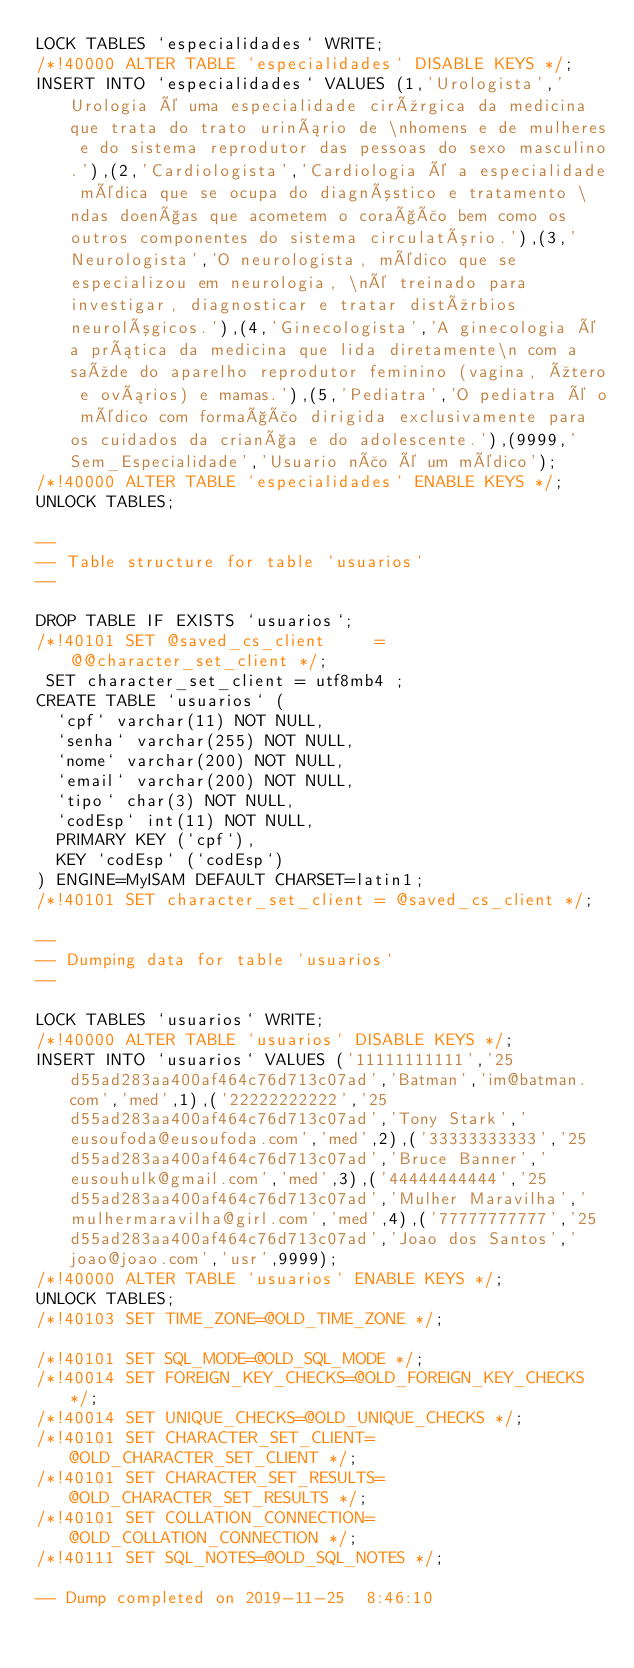Convert code to text. <code><loc_0><loc_0><loc_500><loc_500><_SQL_>LOCK TABLES `especialidades` WRITE;
/*!40000 ALTER TABLE `especialidades` DISABLE KEYS */;
INSERT INTO `especialidades` VALUES (1,'Urologista','Urologia é uma especialidade cirúrgica da medicina que trata do trato urinário de \nhomens e de mulheres e do sistema reprodutor das pessoas do sexo masculino.'),(2,'Cardiologista','Cardiologia é a especialidade médica que se ocupa do diagnóstico e tratamento \ndas doenças que acometem o coração bem como os outros componentes do sistema circulatório.'),(3,'Neurologista','O neurologista, médico que se especializou em neurologia, \né treinado para investigar, diagnosticar e tratar distúrbios neurológicos.'),(4,'Ginecologista','A ginecologia é a prática da medicina que lida diretamente\n com a saúde do aparelho reprodutor feminino (vagina, útero e ovários) e mamas.'),(5,'Pediatra','O pediatra é o médico com formação dirigida exclusivamente para os cuidados da criança e do adolescente.'),(9999,'Sem_Especialidade','Usuario não é um médico');
/*!40000 ALTER TABLE `especialidades` ENABLE KEYS */;
UNLOCK TABLES;

--
-- Table structure for table `usuarios`
--

DROP TABLE IF EXISTS `usuarios`;
/*!40101 SET @saved_cs_client     = @@character_set_client */;
 SET character_set_client = utf8mb4 ;
CREATE TABLE `usuarios` (
  `cpf` varchar(11) NOT NULL,
  `senha` varchar(255) NOT NULL,
  `nome` varchar(200) NOT NULL,
  `email` varchar(200) NOT NULL,
  `tipo` char(3) NOT NULL,
  `codEsp` int(11) NOT NULL,
  PRIMARY KEY (`cpf`),
  KEY `codEsp` (`codEsp`)
) ENGINE=MyISAM DEFAULT CHARSET=latin1;
/*!40101 SET character_set_client = @saved_cs_client */;

--
-- Dumping data for table `usuarios`
--

LOCK TABLES `usuarios` WRITE;
/*!40000 ALTER TABLE `usuarios` DISABLE KEYS */;
INSERT INTO `usuarios` VALUES ('11111111111','25d55ad283aa400af464c76d713c07ad','Batman','im@batman.com','med',1),('22222222222','25d55ad283aa400af464c76d713c07ad','Tony Stark','eusoufoda@eusoufoda.com','med',2),('33333333333','25d55ad283aa400af464c76d713c07ad','Bruce Banner','eusouhulk@gmail.com','med',3),('44444444444','25d55ad283aa400af464c76d713c07ad','Mulher Maravilha','mulhermaravilha@girl.com','med',4),('77777777777','25d55ad283aa400af464c76d713c07ad','Joao dos Santos','joao@joao.com','usr',9999);
/*!40000 ALTER TABLE `usuarios` ENABLE KEYS */;
UNLOCK TABLES;
/*!40103 SET TIME_ZONE=@OLD_TIME_ZONE */;

/*!40101 SET SQL_MODE=@OLD_SQL_MODE */;
/*!40014 SET FOREIGN_KEY_CHECKS=@OLD_FOREIGN_KEY_CHECKS */;
/*!40014 SET UNIQUE_CHECKS=@OLD_UNIQUE_CHECKS */;
/*!40101 SET CHARACTER_SET_CLIENT=@OLD_CHARACTER_SET_CLIENT */;
/*!40101 SET CHARACTER_SET_RESULTS=@OLD_CHARACTER_SET_RESULTS */;
/*!40101 SET COLLATION_CONNECTION=@OLD_COLLATION_CONNECTION */;
/*!40111 SET SQL_NOTES=@OLD_SQL_NOTES */;

-- Dump completed on 2019-11-25  8:46:10
</code> 